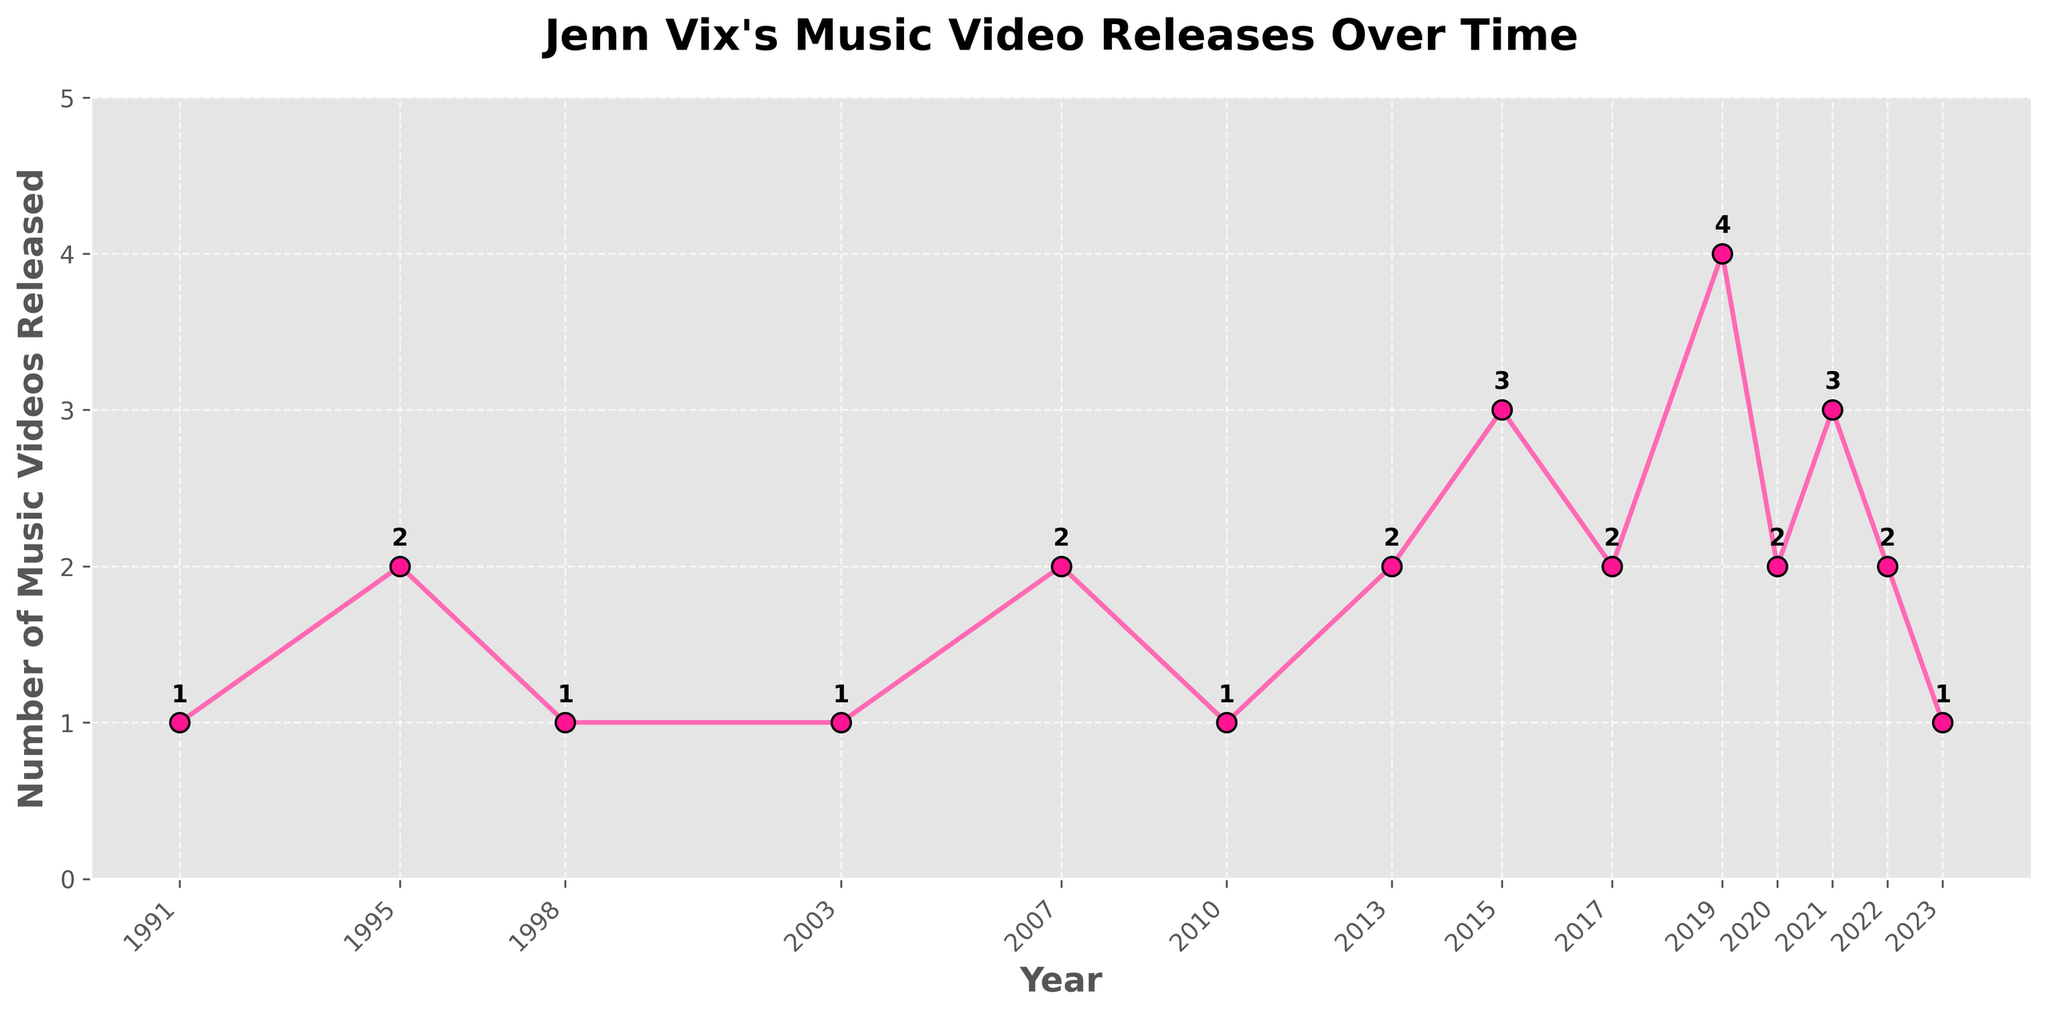What's the highest number of music videos Jenn Vix released in a single year? Look for the year with the highest vertical position on the plot-lines. The year 2019 has the highest peak at 4 music videos.
Answer: 4 In which year did Jenn Vix release exactly 3 music videos? Find the points on the graph where the y-value is 3. These points correspond to the years 2015 and 2021.
Answer: 2015 and 2021 During which time period did Jenn Vix have the most consistent number of music video releases? Identify the period with the least fluctuation in the y-values. The period 2020 to 2023 has values ranging narrowly between 1 and 3.
Answer: 2020-2023 How many years saw only 1 music video release by Jenn Vix? Count the points on the graph where the y-value is 1. The years are 1991, 1998, 2003, 2010, and 2023.
Answer: 5 Between 2010 and 2015, did the number of music videos released by Jenn Vix increase, decrease, or remain the same? Compare the y-values at 2010 and 2015. In 2010, 1 video was released; in 2015, 3 videos were released, showing an increase.
Answer: Increase In which year did Jenn Vix see her first increase in the number of music videos compared to the previous year? Compare subsequent y-values and identify the first instance of an increase. This occurs from 1991 (1 video) to 1995 (2 videos).
Answer: 1995 What was the average number of music videos released per year from 2007 to 2023? Sum all values from 2007 to 2023 and then divide by the number of years. The sum is (2 + 1 + 2 + 3 + 2 + 4 + 2 + 3 + 2 + 1) = 22. There are 11 years. The average is 22/11 = 2.
Answer: 2 How often did Jenn Vix release more than 2 music videos in a year? Count the points where y-values are greater than 2. The years are 2015, 2019, and 2021.
Answer: 3 If you combine the total number of music videos released after 2015, how many would there be? Sum the y-values from 2016 to 2023. The sum is (2 + 4 + 2 + 3 + 2 + 1) = 14.
Answer: 14 Which year had the largest increase in the number of music videos released compared to the previous year? Look for the maximum difference in y-values between consecutive years. The maximum increase is from 2018 (2 videos) to 2019 (4 videos), an increase of 2 videos.
Answer: 2019 